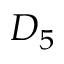<formula> <loc_0><loc_0><loc_500><loc_500>D _ { 5 }</formula> 